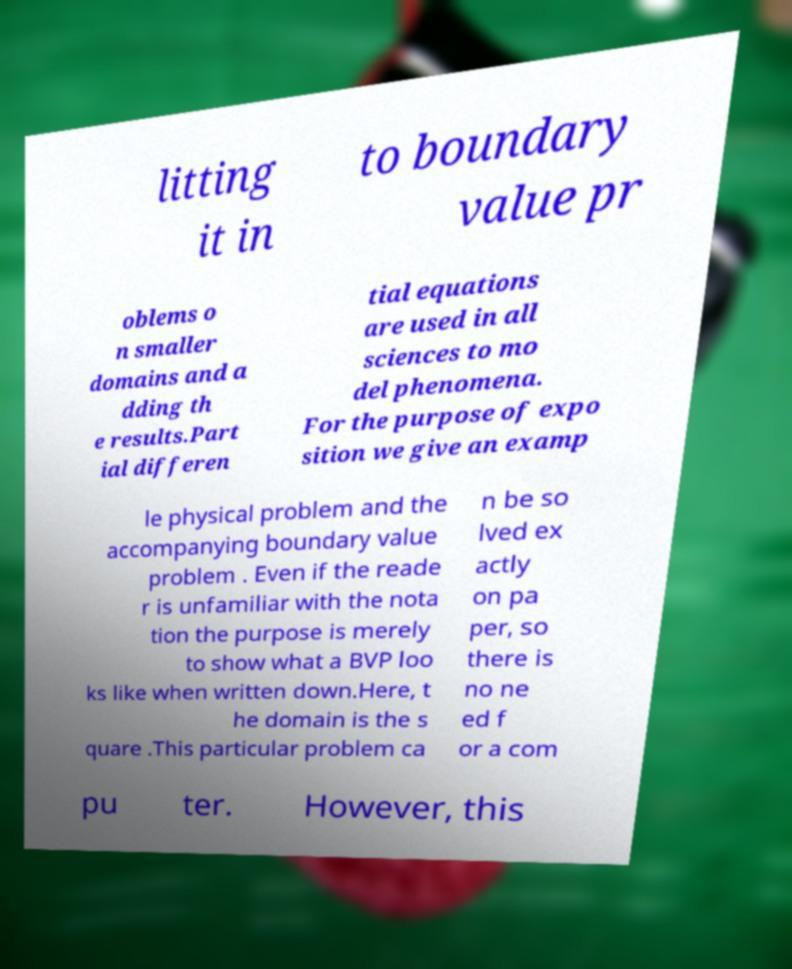I need the written content from this picture converted into text. Can you do that? litting it in to boundary value pr oblems o n smaller domains and a dding th e results.Part ial differen tial equations are used in all sciences to mo del phenomena. For the purpose of expo sition we give an examp le physical problem and the accompanying boundary value problem . Even if the reade r is unfamiliar with the nota tion the purpose is merely to show what a BVP loo ks like when written down.Here, t he domain is the s quare .This particular problem ca n be so lved ex actly on pa per, so there is no ne ed f or a com pu ter. However, this 